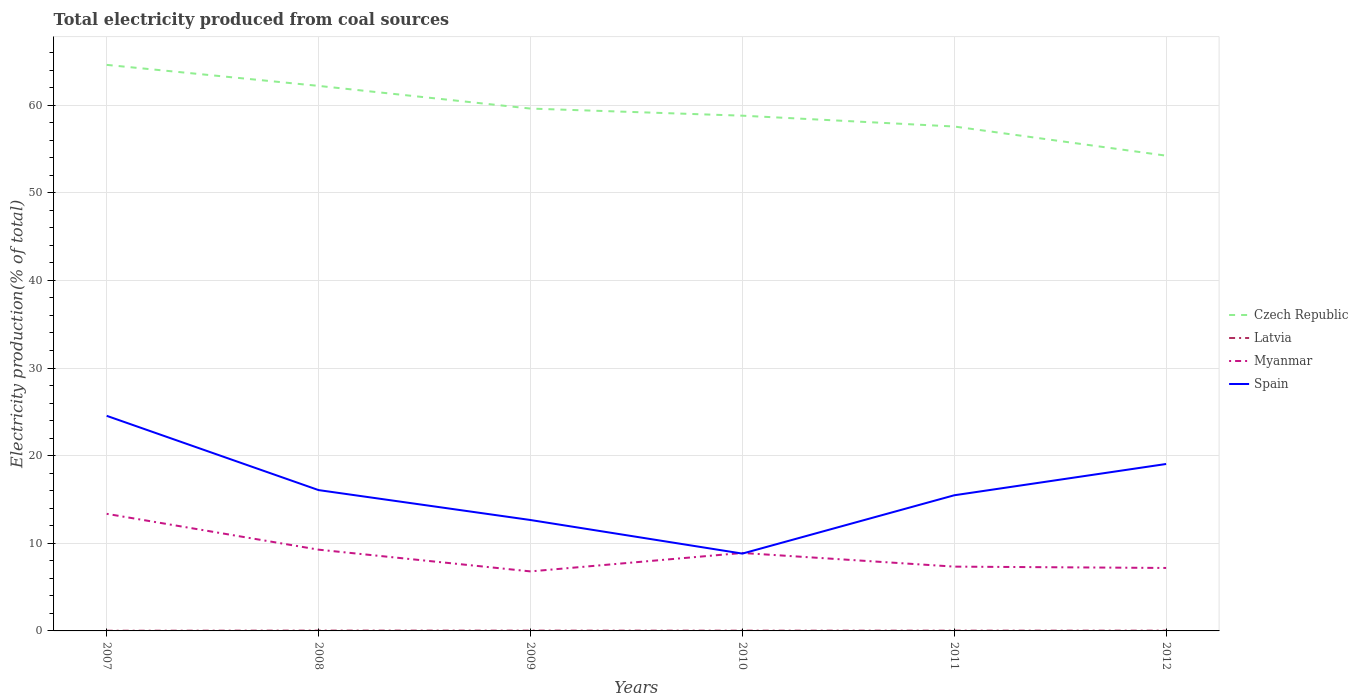Is the number of lines equal to the number of legend labels?
Your answer should be very brief. Yes. Across all years, what is the maximum total electricity produced in Czech Republic?
Give a very brief answer. 54.23. What is the total total electricity produced in Spain in the graph?
Your answer should be very brief. 9.07. What is the difference between the highest and the second highest total electricity produced in Myanmar?
Make the answer very short. 6.57. Is the total electricity produced in Myanmar strictly greater than the total electricity produced in Czech Republic over the years?
Give a very brief answer. Yes. How many lines are there?
Make the answer very short. 4. What is the difference between two consecutive major ticks on the Y-axis?
Provide a succinct answer. 10. Are the values on the major ticks of Y-axis written in scientific E-notation?
Provide a succinct answer. No. Does the graph contain any zero values?
Your response must be concise. No. What is the title of the graph?
Your answer should be compact. Total electricity produced from coal sources. Does "Estonia" appear as one of the legend labels in the graph?
Your answer should be very brief. No. What is the label or title of the X-axis?
Give a very brief answer. Years. What is the Electricity production(% of total) in Czech Republic in 2007?
Your response must be concise. 64.59. What is the Electricity production(% of total) of Latvia in 2007?
Offer a terse response. 0.02. What is the Electricity production(% of total) in Myanmar in 2007?
Ensure brevity in your answer.  13.36. What is the Electricity production(% of total) of Spain in 2007?
Offer a very short reply. 24.54. What is the Electricity production(% of total) of Czech Republic in 2008?
Provide a succinct answer. 62.19. What is the Electricity production(% of total) in Latvia in 2008?
Make the answer very short. 0.04. What is the Electricity production(% of total) in Myanmar in 2008?
Your response must be concise. 9.27. What is the Electricity production(% of total) in Spain in 2008?
Provide a short and direct response. 16.07. What is the Electricity production(% of total) in Czech Republic in 2009?
Make the answer very short. 59.6. What is the Electricity production(% of total) in Latvia in 2009?
Offer a very short reply. 0.04. What is the Electricity production(% of total) of Myanmar in 2009?
Keep it short and to the point. 6.79. What is the Electricity production(% of total) in Spain in 2009?
Provide a short and direct response. 12.66. What is the Electricity production(% of total) in Czech Republic in 2010?
Your response must be concise. 58.79. What is the Electricity production(% of total) of Latvia in 2010?
Provide a succinct answer. 0.03. What is the Electricity production(% of total) of Myanmar in 2010?
Your answer should be very brief. 8.9. What is the Electricity production(% of total) of Spain in 2010?
Your answer should be compact. 8.82. What is the Electricity production(% of total) of Czech Republic in 2011?
Offer a terse response. 57.56. What is the Electricity production(% of total) of Latvia in 2011?
Offer a very short reply. 0.03. What is the Electricity production(% of total) of Myanmar in 2011?
Offer a terse response. 7.34. What is the Electricity production(% of total) in Spain in 2011?
Your answer should be very brief. 15.48. What is the Electricity production(% of total) of Czech Republic in 2012?
Ensure brevity in your answer.  54.23. What is the Electricity production(% of total) of Latvia in 2012?
Ensure brevity in your answer.  0.03. What is the Electricity production(% of total) of Myanmar in 2012?
Your answer should be very brief. 7.18. What is the Electricity production(% of total) in Spain in 2012?
Provide a succinct answer. 19.05. Across all years, what is the maximum Electricity production(% of total) of Czech Republic?
Provide a short and direct response. 64.59. Across all years, what is the maximum Electricity production(% of total) in Latvia?
Your response must be concise. 0.04. Across all years, what is the maximum Electricity production(% of total) of Myanmar?
Offer a terse response. 13.36. Across all years, what is the maximum Electricity production(% of total) of Spain?
Your answer should be compact. 24.54. Across all years, what is the minimum Electricity production(% of total) in Czech Republic?
Provide a short and direct response. 54.23. Across all years, what is the minimum Electricity production(% of total) in Latvia?
Ensure brevity in your answer.  0.02. Across all years, what is the minimum Electricity production(% of total) in Myanmar?
Ensure brevity in your answer.  6.79. Across all years, what is the minimum Electricity production(% of total) of Spain?
Provide a succinct answer. 8.82. What is the total Electricity production(% of total) in Czech Republic in the graph?
Your response must be concise. 356.97. What is the total Electricity production(% of total) in Latvia in the graph?
Your answer should be very brief. 0.19. What is the total Electricity production(% of total) in Myanmar in the graph?
Offer a very short reply. 52.84. What is the total Electricity production(% of total) in Spain in the graph?
Give a very brief answer. 96.62. What is the difference between the Electricity production(% of total) of Czech Republic in 2007 and that in 2008?
Offer a terse response. 2.4. What is the difference between the Electricity production(% of total) in Latvia in 2007 and that in 2008?
Your response must be concise. -0.02. What is the difference between the Electricity production(% of total) in Myanmar in 2007 and that in 2008?
Ensure brevity in your answer.  4.09. What is the difference between the Electricity production(% of total) in Spain in 2007 and that in 2008?
Keep it short and to the point. 8.47. What is the difference between the Electricity production(% of total) in Czech Republic in 2007 and that in 2009?
Keep it short and to the point. 4.99. What is the difference between the Electricity production(% of total) of Latvia in 2007 and that in 2009?
Give a very brief answer. -0.01. What is the difference between the Electricity production(% of total) in Myanmar in 2007 and that in 2009?
Your answer should be compact. 6.57. What is the difference between the Electricity production(% of total) in Spain in 2007 and that in 2009?
Give a very brief answer. 11.89. What is the difference between the Electricity production(% of total) of Czech Republic in 2007 and that in 2010?
Offer a very short reply. 5.8. What is the difference between the Electricity production(% of total) in Latvia in 2007 and that in 2010?
Your response must be concise. -0.01. What is the difference between the Electricity production(% of total) of Myanmar in 2007 and that in 2010?
Offer a very short reply. 4.47. What is the difference between the Electricity production(% of total) in Spain in 2007 and that in 2010?
Ensure brevity in your answer.  15.72. What is the difference between the Electricity production(% of total) in Czech Republic in 2007 and that in 2011?
Your answer should be very brief. 7.03. What is the difference between the Electricity production(% of total) of Latvia in 2007 and that in 2011?
Provide a succinct answer. -0.01. What is the difference between the Electricity production(% of total) of Myanmar in 2007 and that in 2011?
Make the answer very short. 6.02. What is the difference between the Electricity production(% of total) in Spain in 2007 and that in 2011?
Keep it short and to the point. 9.07. What is the difference between the Electricity production(% of total) in Czech Republic in 2007 and that in 2012?
Your answer should be very brief. 10.36. What is the difference between the Electricity production(% of total) in Latvia in 2007 and that in 2012?
Provide a succinct answer. -0.01. What is the difference between the Electricity production(% of total) of Myanmar in 2007 and that in 2012?
Give a very brief answer. 6.18. What is the difference between the Electricity production(% of total) in Spain in 2007 and that in 2012?
Your answer should be compact. 5.5. What is the difference between the Electricity production(% of total) in Czech Republic in 2008 and that in 2009?
Make the answer very short. 2.59. What is the difference between the Electricity production(% of total) of Latvia in 2008 and that in 2009?
Offer a very short reply. 0. What is the difference between the Electricity production(% of total) in Myanmar in 2008 and that in 2009?
Offer a terse response. 2.48. What is the difference between the Electricity production(% of total) in Spain in 2008 and that in 2009?
Your response must be concise. 3.41. What is the difference between the Electricity production(% of total) of Czech Republic in 2008 and that in 2010?
Your answer should be very brief. 3.4. What is the difference between the Electricity production(% of total) in Latvia in 2008 and that in 2010?
Make the answer very short. 0.01. What is the difference between the Electricity production(% of total) in Myanmar in 2008 and that in 2010?
Ensure brevity in your answer.  0.38. What is the difference between the Electricity production(% of total) in Spain in 2008 and that in 2010?
Give a very brief answer. 7.25. What is the difference between the Electricity production(% of total) in Czech Republic in 2008 and that in 2011?
Your answer should be very brief. 4.64. What is the difference between the Electricity production(% of total) of Latvia in 2008 and that in 2011?
Ensure brevity in your answer.  0.01. What is the difference between the Electricity production(% of total) in Myanmar in 2008 and that in 2011?
Offer a very short reply. 1.94. What is the difference between the Electricity production(% of total) in Spain in 2008 and that in 2011?
Make the answer very short. 0.59. What is the difference between the Electricity production(% of total) in Czech Republic in 2008 and that in 2012?
Give a very brief answer. 7.96. What is the difference between the Electricity production(% of total) in Latvia in 2008 and that in 2012?
Offer a very short reply. 0.01. What is the difference between the Electricity production(% of total) of Myanmar in 2008 and that in 2012?
Make the answer very short. 2.09. What is the difference between the Electricity production(% of total) in Spain in 2008 and that in 2012?
Keep it short and to the point. -2.98. What is the difference between the Electricity production(% of total) in Czech Republic in 2009 and that in 2010?
Your response must be concise. 0.81. What is the difference between the Electricity production(% of total) of Latvia in 2009 and that in 2010?
Give a very brief answer. 0.01. What is the difference between the Electricity production(% of total) of Myanmar in 2009 and that in 2010?
Offer a very short reply. -2.1. What is the difference between the Electricity production(% of total) in Spain in 2009 and that in 2010?
Give a very brief answer. 3.83. What is the difference between the Electricity production(% of total) in Czech Republic in 2009 and that in 2011?
Give a very brief answer. 2.05. What is the difference between the Electricity production(% of total) of Latvia in 2009 and that in 2011?
Offer a terse response. 0. What is the difference between the Electricity production(% of total) in Myanmar in 2009 and that in 2011?
Your response must be concise. -0.54. What is the difference between the Electricity production(% of total) in Spain in 2009 and that in 2011?
Offer a very short reply. -2.82. What is the difference between the Electricity production(% of total) of Czech Republic in 2009 and that in 2012?
Ensure brevity in your answer.  5.37. What is the difference between the Electricity production(% of total) in Latvia in 2009 and that in 2012?
Your answer should be very brief. 0. What is the difference between the Electricity production(% of total) in Myanmar in 2009 and that in 2012?
Offer a terse response. -0.39. What is the difference between the Electricity production(% of total) of Spain in 2009 and that in 2012?
Your answer should be compact. -6.39. What is the difference between the Electricity production(% of total) in Czech Republic in 2010 and that in 2011?
Your answer should be compact. 1.24. What is the difference between the Electricity production(% of total) of Latvia in 2010 and that in 2011?
Ensure brevity in your answer.  -0. What is the difference between the Electricity production(% of total) in Myanmar in 2010 and that in 2011?
Provide a short and direct response. 1.56. What is the difference between the Electricity production(% of total) in Spain in 2010 and that in 2011?
Your response must be concise. -6.66. What is the difference between the Electricity production(% of total) in Czech Republic in 2010 and that in 2012?
Your response must be concise. 4.56. What is the difference between the Electricity production(% of total) of Latvia in 2010 and that in 2012?
Ensure brevity in your answer.  -0. What is the difference between the Electricity production(% of total) in Myanmar in 2010 and that in 2012?
Keep it short and to the point. 1.71. What is the difference between the Electricity production(% of total) in Spain in 2010 and that in 2012?
Your answer should be compact. -10.22. What is the difference between the Electricity production(% of total) in Czech Republic in 2011 and that in 2012?
Offer a very short reply. 3.33. What is the difference between the Electricity production(% of total) in Myanmar in 2011 and that in 2012?
Make the answer very short. 0.15. What is the difference between the Electricity production(% of total) of Spain in 2011 and that in 2012?
Ensure brevity in your answer.  -3.57. What is the difference between the Electricity production(% of total) of Czech Republic in 2007 and the Electricity production(% of total) of Latvia in 2008?
Your answer should be very brief. 64.55. What is the difference between the Electricity production(% of total) in Czech Republic in 2007 and the Electricity production(% of total) in Myanmar in 2008?
Your answer should be compact. 55.32. What is the difference between the Electricity production(% of total) of Czech Republic in 2007 and the Electricity production(% of total) of Spain in 2008?
Keep it short and to the point. 48.52. What is the difference between the Electricity production(% of total) of Latvia in 2007 and the Electricity production(% of total) of Myanmar in 2008?
Give a very brief answer. -9.25. What is the difference between the Electricity production(% of total) of Latvia in 2007 and the Electricity production(% of total) of Spain in 2008?
Provide a succinct answer. -16.05. What is the difference between the Electricity production(% of total) of Myanmar in 2007 and the Electricity production(% of total) of Spain in 2008?
Offer a very short reply. -2.71. What is the difference between the Electricity production(% of total) of Czech Republic in 2007 and the Electricity production(% of total) of Latvia in 2009?
Ensure brevity in your answer.  64.56. What is the difference between the Electricity production(% of total) in Czech Republic in 2007 and the Electricity production(% of total) in Myanmar in 2009?
Your response must be concise. 57.8. What is the difference between the Electricity production(% of total) in Czech Republic in 2007 and the Electricity production(% of total) in Spain in 2009?
Keep it short and to the point. 51.94. What is the difference between the Electricity production(% of total) of Latvia in 2007 and the Electricity production(% of total) of Myanmar in 2009?
Your response must be concise. -6.77. What is the difference between the Electricity production(% of total) in Latvia in 2007 and the Electricity production(% of total) in Spain in 2009?
Your answer should be very brief. -12.63. What is the difference between the Electricity production(% of total) of Myanmar in 2007 and the Electricity production(% of total) of Spain in 2009?
Make the answer very short. 0.71. What is the difference between the Electricity production(% of total) in Czech Republic in 2007 and the Electricity production(% of total) in Latvia in 2010?
Your response must be concise. 64.56. What is the difference between the Electricity production(% of total) in Czech Republic in 2007 and the Electricity production(% of total) in Myanmar in 2010?
Your answer should be compact. 55.7. What is the difference between the Electricity production(% of total) in Czech Republic in 2007 and the Electricity production(% of total) in Spain in 2010?
Give a very brief answer. 55.77. What is the difference between the Electricity production(% of total) in Latvia in 2007 and the Electricity production(% of total) in Myanmar in 2010?
Your response must be concise. -8.87. What is the difference between the Electricity production(% of total) of Latvia in 2007 and the Electricity production(% of total) of Spain in 2010?
Offer a very short reply. -8.8. What is the difference between the Electricity production(% of total) in Myanmar in 2007 and the Electricity production(% of total) in Spain in 2010?
Give a very brief answer. 4.54. What is the difference between the Electricity production(% of total) in Czech Republic in 2007 and the Electricity production(% of total) in Latvia in 2011?
Ensure brevity in your answer.  64.56. What is the difference between the Electricity production(% of total) in Czech Republic in 2007 and the Electricity production(% of total) in Myanmar in 2011?
Offer a terse response. 57.25. What is the difference between the Electricity production(% of total) of Czech Republic in 2007 and the Electricity production(% of total) of Spain in 2011?
Make the answer very short. 49.11. What is the difference between the Electricity production(% of total) in Latvia in 2007 and the Electricity production(% of total) in Myanmar in 2011?
Offer a very short reply. -7.32. What is the difference between the Electricity production(% of total) in Latvia in 2007 and the Electricity production(% of total) in Spain in 2011?
Make the answer very short. -15.46. What is the difference between the Electricity production(% of total) of Myanmar in 2007 and the Electricity production(% of total) of Spain in 2011?
Your response must be concise. -2.12. What is the difference between the Electricity production(% of total) in Czech Republic in 2007 and the Electricity production(% of total) in Latvia in 2012?
Your response must be concise. 64.56. What is the difference between the Electricity production(% of total) in Czech Republic in 2007 and the Electricity production(% of total) in Myanmar in 2012?
Offer a terse response. 57.41. What is the difference between the Electricity production(% of total) in Czech Republic in 2007 and the Electricity production(% of total) in Spain in 2012?
Ensure brevity in your answer.  45.54. What is the difference between the Electricity production(% of total) in Latvia in 2007 and the Electricity production(% of total) in Myanmar in 2012?
Provide a short and direct response. -7.16. What is the difference between the Electricity production(% of total) in Latvia in 2007 and the Electricity production(% of total) in Spain in 2012?
Give a very brief answer. -19.03. What is the difference between the Electricity production(% of total) of Myanmar in 2007 and the Electricity production(% of total) of Spain in 2012?
Ensure brevity in your answer.  -5.69. What is the difference between the Electricity production(% of total) in Czech Republic in 2008 and the Electricity production(% of total) in Latvia in 2009?
Provide a succinct answer. 62.16. What is the difference between the Electricity production(% of total) of Czech Republic in 2008 and the Electricity production(% of total) of Myanmar in 2009?
Offer a very short reply. 55.4. What is the difference between the Electricity production(% of total) in Czech Republic in 2008 and the Electricity production(% of total) in Spain in 2009?
Offer a very short reply. 49.54. What is the difference between the Electricity production(% of total) in Latvia in 2008 and the Electricity production(% of total) in Myanmar in 2009?
Give a very brief answer. -6.75. What is the difference between the Electricity production(% of total) in Latvia in 2008 and the Electricity production(% of total) in Spain in 2009?
Your answer should be compact. -12.62. What is the difference between the Electricity production(% of total) of Myanmar in 2008 and the Electricity production(% of total) of Spain in 2009?
Provide a short and direct response. -3.38. What is the difference between the Electricity production(% of total) in Czech Republic in 2008 and the Electricity production(% of total) in Latvia in 2010?
Your response must be concise. 62.16. What is the difference between the Electricity production(% of total) of Czech Republic in 2008 and the Electricity production(% of total) of Myanmar in 2010?
Make the answer very short. 53.3. What is the difference between the Electricity production(% of total) in Czech Republic in 2008 and the Electricity production(% of total) in Spain in 2010?
Give a very brief answer. 53.37. What is the difference between the Electricity production(% of total) in Latvia in 2008 and the Electricity production(% of total) in Myanmar in 2010?
Your answer should be compact. -8.86. What is the difference between the Electricity production(% of total) of Latvia in 2008 and the Electricity production(% of total) of Spain in 2010?
Your answer should be compact. -8.79. What is the difference between the Electricity production(% of total) in Myanmar in 2008 and the Electricity production(% of total) in Spain in 2010?
Your answer should be very brief. 0.45. What is the difference between the Electricity production(% of total) of Czech Republic in 2008 and the Electricity production(% of total) of Latvia in 2011?
Offer a terse response. 62.16. What is the difference between the Electricity production(% of total) in Czech Republic in 2008 and the Electricity production(% of total) in Myanmar in 2011?
Offer a terse response. 54.86. What is the difference between the Electricity production(% of total) in Czech Republic in 2008 and the Electricity production(% of total) in Spain in 2011?
Keep it short and to the point. 46.71. What is the difference between the Electricity production(% of total) of Latvia in 2008 and the Electricity production(% of total) of Myanmar in 2011?
Your answer should be compact. -7.3. What is the difference between the Electricity production(% of total) of Latvia in 2008 and the Electricity production(% of total) of Spain in 2011?
Offer a very short reply. -15.44. What is the difference between the Electricity production(% of total) in Myanmar in 2008 and the Electricity production(% of total) in Spain in 2011?
Provide a short and direct response. -6.21. What is the difference between the Electricity production(% of total) in Czech Republic in 2008 and the Electricity production(% of total) in Latvia in 2012?
Ensure brevity in your answer.  62.16. What is the difference between the Electricity production(% of total) in Czech Republic in 2008 and the Electricity production(% of total) in Myanmar in 2012?
Provide a succinct answer. 55.01. What is the difference between the Electricity production(% of total) in Czech Republic in 2008 and the Electricity production(% of total) in Spain in 2012?
Give a very brief answer. 43.15. What is the difference between the Electricity production(% of total) in Latvia in 2008 and the Electricity production(% of total) in Myanmar in 2012?
Provide a succinct answer. -7.15. What is the difference between the Electricity production(% of total) of Latvia in 2008 and the Electricity production(% of total) of Spain in 2012?
Keep it short and to the point. -19.01. What is the difference between the Electricity production(% of total) of Myanmar in 2008 and the Electricity production(% of total) of Spain in 2012?
Give a very brief answer. -9.78. What is the difference between the Electricity production(% of total) in Czech Republic in 2009 and the Electricity production(% of total) in Latvia in 2010?
Provide a short and direct response. 59.57. What is the difference between the Electricity production(% of total) in Czech Republic in 2009 and the Electricity production(% of total) in Myanmar in 2010?
Give a very brief answer. 50.71. What is the difference between the Electricity production(% of total) of Czech Republic in 2009 and the Electricity production(% of total) of Spain in 2010?
Provide a short and direct response. 50.78. What is the difference between the Electricity production(% of total) of Latvia in 2009 and the Electricity production(% of total) of Myanmar in 2010?
Ensure brevity in your answer.  -8.86. What is the difference between the Electricity production(% of total) in Latvia in 2009 and the Electricity production(% of total) in Spain in 2010?
Your answer should be very brief. -8.79. What is the difference between the Electricity production(% of total) in Myanmar in 2009 and the Electricity production(% of total) in Spain in 2010?
Your answer should be compact. -2.03. What is the difference between the Electricity production(% of total) in Czech Republic in 2009 and the Electricity production(% of total) in Latvia in 2011?
Ensure brevity in your answer.  59.57. What is the difference between the Electricity production(% of total) in Czech Republic in 2009 and the Electricity production(% of total) in Myanmar in 2011?
Provide a succinct answer. 52.27. What is the difference between the Electricity production(% of total) in Czech Republic in 2009 and the Electricity production(% of total) in Spain in 2011?
Provide a short and direct response. 44.13. What is the difference between the Electricity production(% of total) of Latvia in 2009 and the Electricity production(% of total) of Myanmar in 2011?
Offer a very short reply. -7.3. What is the difference between the Electricity production(% of total) of Latvia in 2009 and the Electricity production(% of total) of Spain in 2011?
Ensure brevity in your answer.  -15.44. What is the difference between the Electricity production(% of total) in Myanmar in 2009 and the Electricity production(% of total) in Spain in 2011?
Your answer should be compact. -8.69. What is the difference between the Electricity production(% of total) of Czech Republic in 2009 and the Electricity production(% of total) of Latvia in 2012?
Your answer should be compact. 59.57. What is the difference between the Electricity production(% of total) in Czech Republic in 2009 and the Electricity production(% of total) in Myanmar in 2012?
Offer a terse response. 52.42. What is the difference between the Electricity production(% of total) of Czech Republic in 2009 and the Electricity production(% of total) of Spain in 2012?
Keep it short and to the point. 40.56. What is the difference between the Electricity production(% of total) of Latvia in 2009 and the Electricity production(% of total) of Myanmar in 2012?
Make the answer very short. -7.15. What is the difference between the Electricity production(% of total) of Latvia in 2009 and the Electricity production(% of total) of Spain in 2012?
Your answer should be compact. -19.01. What is the difference between the Electricity production(% of total) in Myanmar in 2009 and the Electricity production(% of total) in Spain in 2012?
Give a very brief answer. -12.26. What is the difference between the Electricity production(% of total) of Czech Republic in 2010 and the Electricity production(% of total) of Latvia in 2011?
Offer a terse response. 58.76. What is the difference between the Electricity production(% of total) of Czech Republic in 2010 and the Electricity production(% of total) of Myanmar in 2011?
Offer a terse response. 51.46. What is the difference between the Electricity production(% of total) in Czech Republic in 2010 and the Electricity production(% of total) in Spain in 2011?
Provide a short and direct response. 43.31. What is the difference between the Electricity production(% of total) in Latvia in 2010 and the Electricity production(% of total) in Myanmar in 2011?
Keep it short and to the point. -7.31. What is the difference between the Electricity production(% of total) of Latvia in 2010 and the Electricity production(% of total) of Spain in 2011?
Make the answer very short. -15.45. What is the difference between the Electricity production(% of total) in Myanmar in 2010 and the Electricity production(% of total) in Spain in 2011?
Make the answer very short. -6.58. What is the difference between the Electricity production(% of total) of Czech Republic in 2010 and the Electricity production(% of total) of Latvia in 2012?
Provide a short and direct response. 58.76. What is the difference between the Electricity production(% of total) of Czech Republic in 2010 and the Electricity production(% of total) of Myanmar in 2012?
Offer a terse response. 51.61. What is the difference between the Electricity production(% of total) in Czech Republic in 2010 and the Electricity production(% of total) in Spain in 2012?
Ensure brevity in your answer.  39.75. What is the difference between the Electricity production(% of total) in Latvia in 2010 and the Electricity production(% of total) in Myanmar in 2012?
Offer a terse response. -7.15. What is the difference between the Electricity production(% of total) of Latvia in 2010 and the Electricity production(% of total) of Spain in 2012?
Offer a very short reply. -19.02. What is the difference between the Electricity production(% of total) of Myanmar in 2010 and the Electricity production(% of total) of Spain in 2012?
Offer a very short reply. -10.15. What is the difference between the Electricity production(% of total) in Czech Republic in 2011 and the Electricity production(% of total) in Latvia in 2012?
Offer a terse response. 57.52. What is the difference between the Electricity production(% of total) in Czech Republic in 2011 and the Electricity production(% of total) in Myanmar in 2012?
Your response must be concise. 50.37. What is the difference between the Electricity production(% of total) in Czech Republic in 2011 and the Electricity production(% of total) in Spain in 2012?
Offer a terse response. 38.51. What is the difference between the Electricity production(% of total) of Latvia in 2011 and the Electricity production(% of total) of Myanmar in 2012?
Provide a succinct answer. -7.15. What is the difference between the Electricity production(% of total) in Latvia in 2011 and the Electricity production(% of total) in Spain in 2012?
Offer a very short reply. -19.02. What is the difference between the Electricity production(% of total) of Myanmar in 2011 and the Electricity production(% of total) of Spain in 2012?
Your answer should be very brief. -11.71. What is the average Electricity production(% of total) of Czech Republic per year?
Your response must be concise. 59.5. What is the average Electricity production(% of total) in Latvia per year?
Give a very brief answer. 0.03. What is the average Electricity production(% of total) of Myanmar per year?
Ensure brevity in your answer.  8.81. What is the average Electricity production(% of total) in Spain per year?
Your answer should be very brief. 16.1. In the year 2007, what is the difference between the Electricity production(% of total) in Czech Republic and Electricity production(% of total) in Latvia?
Offer a terse response. 64.57. In the year 2007, what is the difference between the Electricity production(% of total) of Czech Republic and Electricity production(% of total) of Myanmar?
Offer a terse response. 51.23. In the year 2007, what is the difference between the Electricity production(% of total) of Czech Republic and Electricity production(% of total) of Spain?
Give a very brief answer. 40.05. In the year 2007, what is the difference between the Electricity production(% of total) in Latvia and Electricity production(% of total) in Myanmar?
Offer a terse response. -13.34. In the year 2007, what is the difference between the Electricity production(% of total) of Latvia and Electricity production(% of total) of Spain?
Give a very brief answer. -24.52. In the year 2007, what is the difference between the Electricity production(% of total) in Myanmar and Electricity production(% of total) in Spain?
Give a very brief answer. -11.18. In the year 2008, what is the difference between the Electricity production(% of total) of Czech Republic and Electricity production(% of total) of Latvia?
Make the answer very short. 62.16. In the year 2008, what is the difference between the Electricity production(% of total) of Czech Republic and Electricity production(% of total) of Myanmar?
Ensure brevity in your answer.  52.92. In the year 2008, what is the difference between the Electricity production(% of total) in Czech Republic and Electricity production(% of total) in Spain?
Offer a very short reply. 46.12. In the year 2008, what is the difference between the Electricity production(% of total) in Latvia and Electricity production(% of total) in Myanmar?
Your response must be concise. -9.23. In the year 2008, what is the difference between the Electricity production(% of total) of Latvia and Electricity production(% of total) of Spain?
Give a very brief answer. -16.03. In the year 2008, what is the difference between the Electricity production(% of total) of Myanmar and Electricity production(% of total) of Spain?
Your answer should be very brief. -6.8. In the year 2009, what is the difference between the Electricity production(% of total) in Czech Republic and Electricity production(% of total) in Latvia?
Offer a very short reply. 59.57. In the year 2009, what is the difference between the Electricity production(% of total) in Czech Republic and Electricity production(% of total) in Myanmar?
Give a very brief answer. 52.81. In the year 2009, what is the difference between the Electricity production(% of total) of Czech Republic and Electricity production(% of total) of Spain?
Your response must be concise. 46.95. In the year 2009, what is the difference between the Electricity production(% of total) of Latvia and Electricity production(% of total) of Myanmar?
Offer a terse response. -6.76. In the year 2009, what is the difference between the Electricity production(% of total) in Latvia and Electricity production(% of total) in Spain?
Provide a succinct answer. -12.62. In the year 2009, what is the difference between the Electricity production(% of total) of Myanmar and Electricity production(% of total) of Spain?
Provide a succinct answer. -5.86. In the year 2010, what is the difference between the Electricity production(% of total) of Czech Republic and Electricity production(% of total) of Latvia?
Offer a terse response. 58.76. In the year 2010, what is the difference between the Electricity production(% of total) of Czech Republic and Electricity production(% of total) of Myanmar?
Ensure brevity in your answer.  49.9. In the year 2010, what is the difference between the Electricity production(% of total) in Czech Republic and Electricity production(% of total) in Spain?
Your answer should be compact. 49.97. In the year 2010, what is the difference between the Electricity production(% of total) of Latvia and Electricity production(% of total) of Myanmar?
Provide a succinct answer. -8.87. In the year 2010, what is the difference between the Electricity production(% of total) of Latvia and Electricity production(% of total) of Spain?
Offer a terse response. -8.79. In the year 2010, what is the difference between the Electricity production(% of total) in Myanmar and Electricity production(% of total) in Spain?
Ensure brevity in your answer.  0.07. In the year 2011, what is the difference between the Electricity production(% of total) in Czech Republic and Electricity production(% of total) in Latvia?
Provide a short and direct response. 57.52. In the year 2011, what is the difference between the Electricity production(% of total) of Czech Republic and Electricity production(% of total) of Myanmar?
Keep it short and to the point. 50.22. In the year 2011, what is the difference between the Electricity production(% of total) in Czech Republic and Electricity production(% of total) in Spain?
Ensure brevity in your answer.  42.08. In the year 2011, what is the difference between the Electricity production(% of total) in Latvia and Electricity production(% of total) in Myanmar?
Keep it short and to the point. -7.3. In the year 2011, what is the difference between the Electricity production(% of total) of Latvia and Electricity production(% of total) of Spain?
Provide a short and direct response. -15.45. In the year 2011, what is the difference between the Electricity production(% of total) in Myanmar and Electricity production(% of total) in Spain?
Provide a succinct answer. -8.14. In the year 2012, what is the difference between the Electricity production(% of total) in Czech Republic and Electricity production(% of total) in Latvia?
Provide a succinct answer. 54.2. In the year 2012, what is the difference between the Electricity production(% of total) in Czech Republic and Electricity production(% of total) in Myanmar?
Ensure brevity in your answer.  47.05. In the year 2012, what is the difference between the Electricity production(% of total) of Czech Republic and Electricity production(% of total) of Spain?
Keep it short and to the point. 35.18. In the year 2012, what is the difference between the Electricity production(% of total) in Latvia and Electricity production(% of total) in Myanmar?
Your response must be concise. -7.15. In the year 2012, what is the difference between the Electricity production(% of total) of Latvia and Electricity production(% of total) of Spain?
Make the answer very short. -19.02. In the year 2012, what is the difference between the Electricity production(% of total) of Myanmar and Electricity production(% of total) of Spain?
Provide a succinct answer. -11.86. What is the ratio of the Electricity production(% of total) of Czech Republic in 2007 to that in 2008?
Give a very brief answer. 1.04. What is the ratio of the Electricity production(% of total) in Latvia in 2007 to that in 2008?
Make the answer very short. 0.55. What is the ratio of the Electricity production(% of total) of Myanmar in 2007 to that in 2008?
Offer a terse response. 1.44. What is the ratio of the Electricity production(% of total) of Spain in 2007 to that in 2008?
Your response must be concise. 1.53. What is the ratio of the Electricity production(% of total) of Czech Republic in 2007 to that in 2009?
Make the answer very short. 1.08. What is the ratio of the Electricity production(% of total) of Latvia in 2007 to that in 2009?
Ensure brevity in your answer.  0.58. What is the ratio of the Electricity production(% of total) in Myanmar in 2007 to that in 2009?
Make the answer very short. 1.97. What is the ratio of the Electricity production(% of total) in Spain in 2007 to that in 2009?
Your answer should be very brief. 1.94. What is the ratio of the Electricity production(% of total) of Czech Republic in 2007 to that in 2010?
Ensure brevity in your answer.  1.1. What is the ratio of the Electricity production(% of total) of Latvia in 2007 to that in 2010?
Offer a very short reply. 0.69. What is the ratio of the Electricity production(% of total) of Myanmar in 2007 to that in 2010?
Offer a very short reply. 1.5. What is the ratio of the Electricity production(% of total) of Spain in 2007 to that in 2010?
Provide a succinct answer. 2.78. What is the ratio of the Electricity production(% of total) in Czech Republic in 2007 to that in 2011?
Ensure brevity in your answer.  1.12. What is the ratio of the Electricity production(% of total) in Latvia in 2007 to that in 2011?
Your answer should be very brief. 0.64. What is the ratio of the Electricity production(% of total) in Myanmar in 2007 to that in 2011?
Your response must be concise. 1.82. What is the ratio of the Electricity production(% of total) in Spain in 2007 to that in 2011?
Your response must be concise. 1.59. What is the ratio of the Electricity production(% of total) of Czech Republic in 2007 to that in 2012?
Keep it short and to the point. 1.19. What is the ratio of the Electricity production(% of total) in Latvia in 2007 to that in 2012?
Your answer should be compact. 0.65. What is the ratio of the Electricity production(% of total) in Myanmar in 2007 to that in 2012?
Provide a short and direct response. 1.86. What is the ratio of the Electricity production(% of total) in Spain in 2007 to that in 2012?
Provide a short and direct response. 1.29. What is the ratio of the Electricity production(% of total) of Czech Republic in 2008 to that in 2009?
Your answer should be very brief. 1.04. What is the ratio of the Electricity production(% of total) of Latvia in 2008 to that in 2009?
Keep it short and to the point. 1.06. What is the ratio of the Electricity production(% of total) in Myanmar in 2008 to that in 2009?
Your answer should be very brief. 1.37. What is the ratio of the Electricity production(% of total) in Spain in 2008 to that in 2009?
Provide a short and direct response. 1.27. What is the ratio of the Electricity production(% of total) of Czech Republic in 2008 to that in 2010?
Keep it short and to the point. 1.06. What is the ratio of the Electricity production(% of total) in Latvia in 2008 to that in 2010?
Provide a short and direct response. 1.26. What is the ratio of the Electricity production(% of total) of Myanmar in 2008 to that in 2010?
Give a very brief answer. 1.04. What is the ratio of the Electricity production(% of total) of Spain in 2008 to that in 2010?
Provide a succinct answer. 1.82. What is the ratio of the Electricity production(% of total) in Czech Republic in 2008 to that in 2011?
Keep it short and to the point. 1.08. What is the ratio of the Electricity production(% of total) in Latvia in 2008 to that in 2011?
Ensure brevity in your answer.  1.16. What is the ratio of the Electricity production(% of total) of Myanmar in 2008 to that in 2011?
Ensure brevity in your answer.  1.26. What is the ratio of the Electricity production(% of total) in Spain in 2008 to that in 2011?
Provide a succinct answer. 1.04. What is the ratio of the Electricity production(% of total) of Czech Republic in 2008 to that in 2012?
Ensure brevity in your answer.  1.15. What is the ratio of the Electricity production(% of total) of Latvia in 2008 to that in 2012?
Ensure brevity in your answer.  1.17. What is the ratio of the Electricity production(% of total) of Myanmar in 2008 to that in 2012?
Make the answer very short. 1.29. What is the ratio of the Electricity production(% of total) of Spain in 2008 to that in 2012?
Provide a short and direct response. 0.84. What is the ratio of the Electricity production(% of total) of Czech Republic in 2009 to that in 2010?
Ensure brevity in your answer.  1.01. What is the ratio of the Electricity production(% of total) in Latvia in 2009 to that in 2010?
Offer a terse response. 1.19. What is the ratio of the Electricity production(% of total) of Myanmar in 2009 to that in 2010?
Your answer should be compact. 0.76. What is the ratio of the Electricity production(% of total) in Spain in 2009 to that in 2010?
Provide a succinct answer. 1.43. What is the ratio of the Electricity production(% of total) of Czech Republic in 2009 to that in 2011?
Give a very brief answer. 1.04. What is the ratio of the Electricity production(% of total) in Latvia in 2009 to that in 2011?
Give a very brief answer. 1.09. What is the ratio of the Electricity production(% of total) of Myanmar in 2009 to that in 2011?
Provide a short and direct response. 0.93. What is the ratio of the Electricity production(% of total) of Spain in 2009 to that in 2011?
Give a very brief answer. 0.82. What is the ratio of the Electricity production(% of total) in Czech Republic in 2009 to that in 2012?
Offer a terse response. 1.1. What is the ratio of the Electricity production(% of total) of Latvia in 2009 to that in 2012?
Offer a very short reply. 1.11. What is the ratio of the Electricity production(% of total) in Myanmar in 2009 to that in 2012?
Your answer should be compact. 0.95. What is the ratio of the Electricity production(% of total) in Spain in 2009 to that in 2012?
Your answer should be compact. 0.66. What is the ratio of the Electricity production(% of total) of Czech Republic in 2010 to that in 2011?
Your response must be concise. 1.02. What is the ratio of the Electricity production(% of total) of Latvia in 2010 to that in 2011?
Give a very brief answer. 0.92. What is the ratio of the Electricity production(% of total) in Myanmar in 2010 to that in 2011?
Offer a very short reply. 1.21. What is the ratio of the Electricity production(% of total) in Spain in 2010 to that in 2011?
Your answer should be compact. 0.57. What is the ratio of the Electricity production(% of total) of Czech Republic in 2010 to that in 2012?
Your answer should be compact. 1.08. What is the ratio of the Electricity production(% of total) in Latvia in 2010 to that in 2012?
Keep it short and to the point. 0.93. What is the ratio of the Electricity production(% of total) in Myanmar in 2010 to that in 2012?
Provide a succinct answer. 1.24. What is the ratio of the Electricity production(% of total) in Spain in 2010 to that in 2012?
Offer a terse response. 0.46. What is the ratio of the Electricity production(% of total) in Czech Republic in 2011 to that in 2012?
Offer a terse response. 1.06. What is the ratio of the Electricity production(% of total) in Latvia in 2011 to that in 2012?
Give a very brief answer. 1.01. What is the ratio of the Electricity production(% of total) in Myanmar in 2011 to that in 2012?
Offer a terse response. 1.02. What is the ratio of the Electricity production(% of total) in Spain in 2011 to that in 2012?
Provide a short and direct response. 0.81. What is the difference between the highest and the second highest Electricity production(% of total) in Czech Republic?
Provide a short and direct response. 2.4. What is the difference between the highest and the second highest Electricity production(% of total) in Latvia?
Provide a succinct answer. 0. What is the difference between the highest and the second highest Electricity production(% of total) of Myanmar?
Provide a succinct answer. 4.09. What is the difference between the highest and the second highest Electricity production(% of total) of Spain?
Provide a succinct answer. 5.5. What is the difference between the highest and the lowest Electricity production(% of total) of Czech Republic?
Give a very brief answer. 10.36. What is the difference between the highest and the lowest Electricity production(% of total) of Latvia?
Keep it short and to the point. 0.02. What is the difference between the highest and the lowest Electricity production(% of total) of Myanmar?
Provide a short and direct response. 6.57. What is the difference between the highest and the lowest Electricity production(% of total) of Spain?
Make the answer very short. 15.72. 